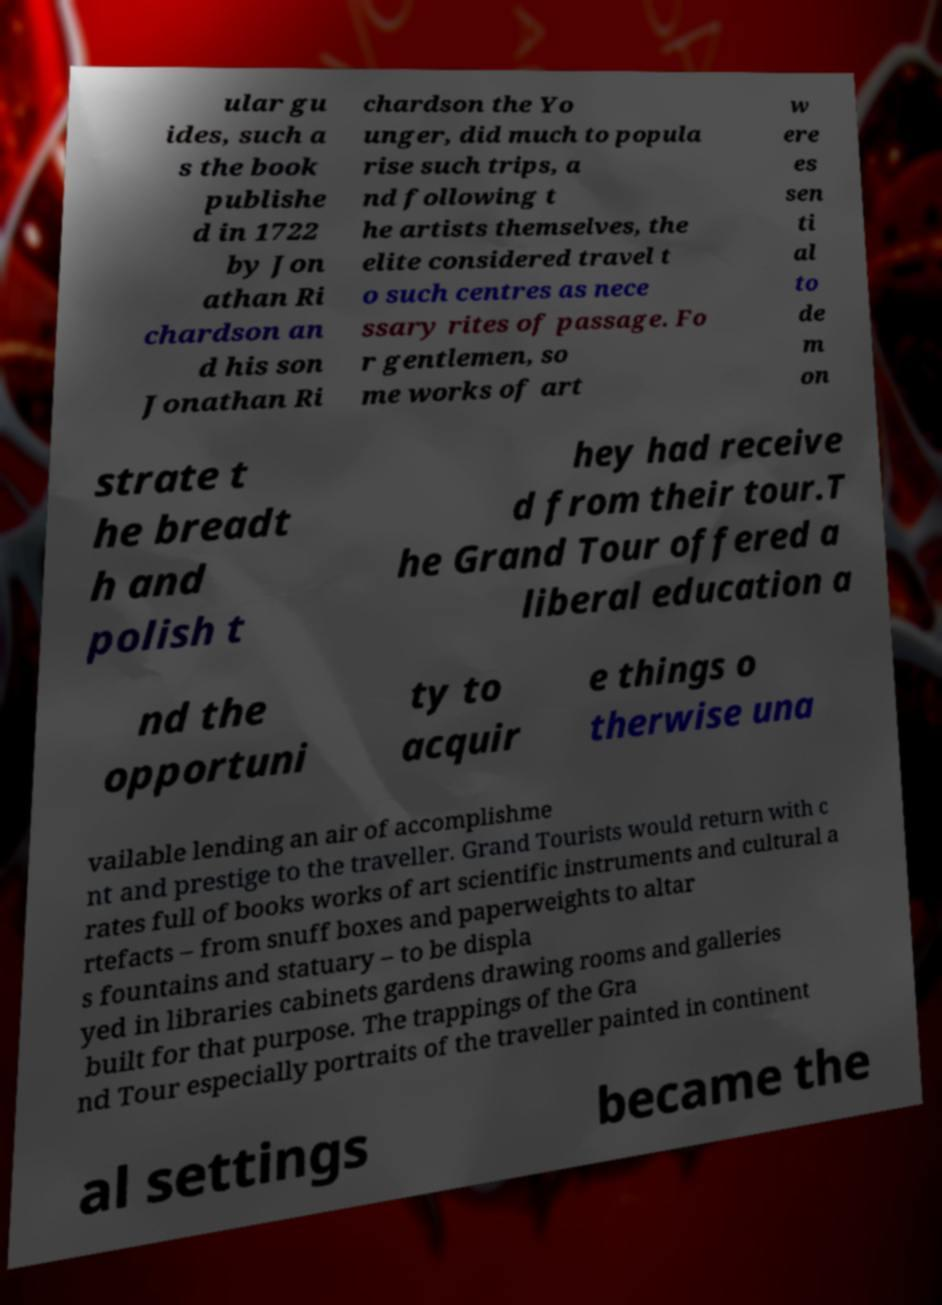Can you read and provide the text displayed in the image?This photo seems to have some interesting text. Can you extract and type it out for me? ular gu ides, such a s the book publishe d in 1722 by Jon athan Ri chardson an d his son Jonathan Ri chardson the Yo unger, did much to popula rise such trips, a nd following t he artists themselves, the elite considered travel t o such centres as nece ssary rites of passage. Fo r gentlemen, so me works of art w ere es sen ti al to de m on strate t he breadt h and polish t hey had receive d from their tour.T he Grand Tour offered a liberal education a nd the opportuni ty to acquir e things o therwise una vailable lending an air of accomplishme nt and prestige to the traveller. Grand Tourists would return with c rates full of books works of art scientific instruments and cultural a rtefacts – from snuff boxes and paperweights to altar s fountains and statuary – to be displa yed in libraries cabinets gardens drawing rooms and galleries built for that purpose. The trappings of the Gra nd Tour especially portraits of the traveller painted in continent al settings became the 